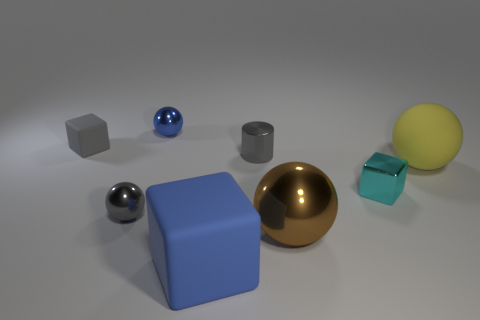There is a gray metal cylinder that is left of the big yellow rubber thing; is there a cyan metal thing that is behind it?
Make the answer very short. No. Does the metal sphere that is to the left of the blue metal ball have the same color as the small ball that is right of the small gray ball?
Your answer should be compact. No. How many brown metal objects have the same size as the gray matte thing?
Your response must be concise. 0. There is a rubber object that is right of the metal cylinder; does it have the same size as the big blue block?
Provide a succinct answer. Yes. What shape is the brown thing?
Give a very brief answer. Sphere. There is a rubber block that is the same color as the cylinder; what is its size?
Keep it short and to the point. Small. Is the material of the big sphere behind the big brown shiny thing the same as the large blue cube?
Your answer should be compact. Yes. Are there any tiny rubber blocks of the same color as the metallic cube?
Your answer should be compact. No. Is the shape of the gray thing that is in front of the small cyan metallic block the same as the small thing that is behind the small gray block?
Offer a very short reply. Yes. Are there any large blocks made of the same material as the large yellow object?
Provide a short and direct response. Yes. 